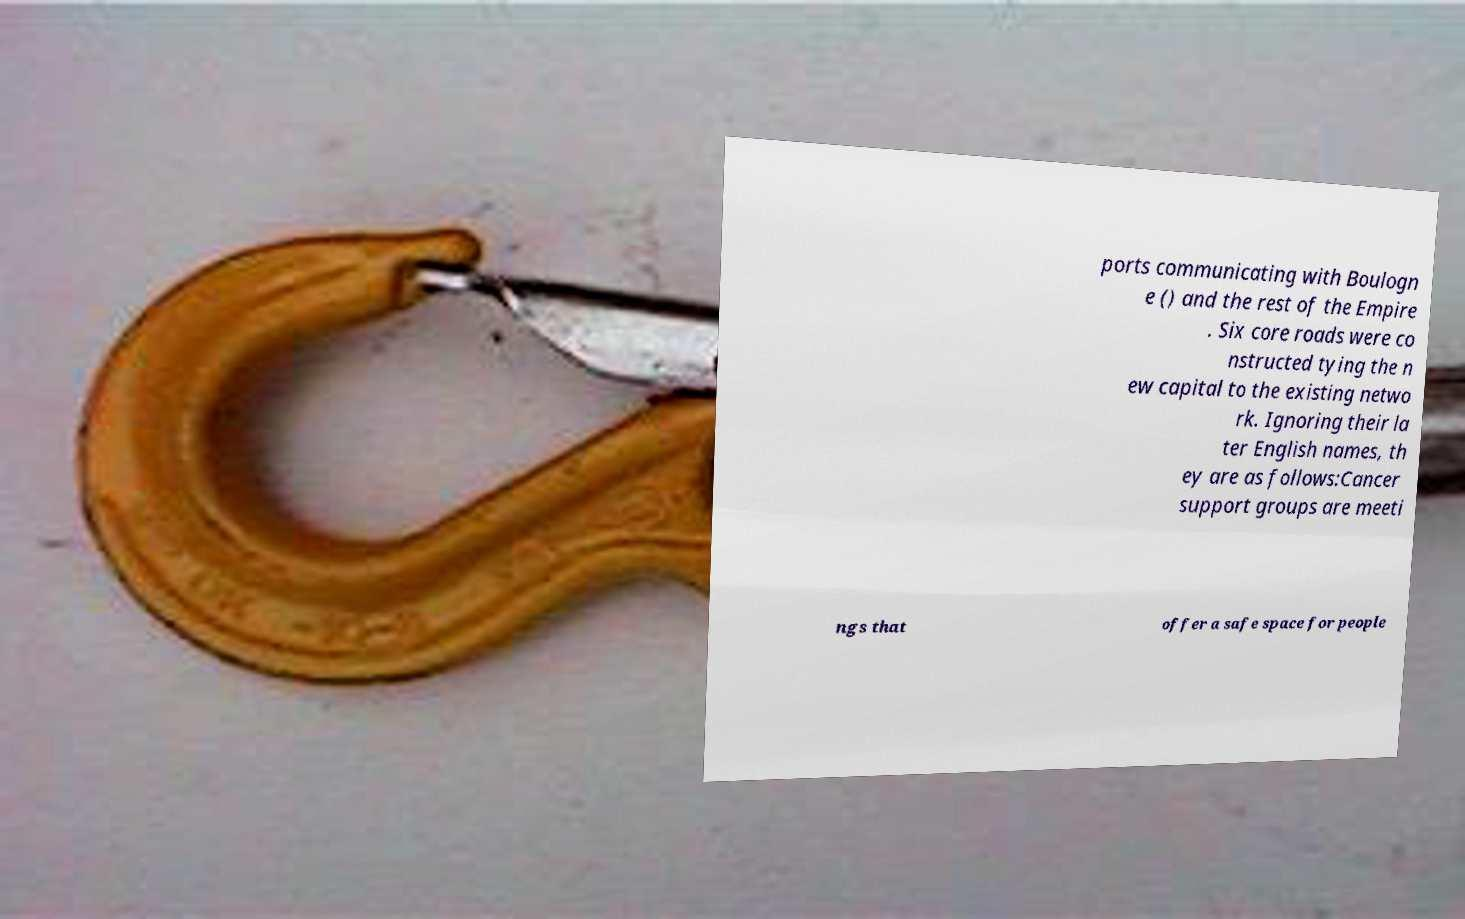Could you extract and type out the text from this image? ports communicating with Boulogn e () and the rest of the Empire . Six core roads were co nstructed tying the n ew capital to the existing netwo rk. Ignoring their la ter English names, th ey are as follows:Cancer support groups are meeti ngs that offer a safe space for people 